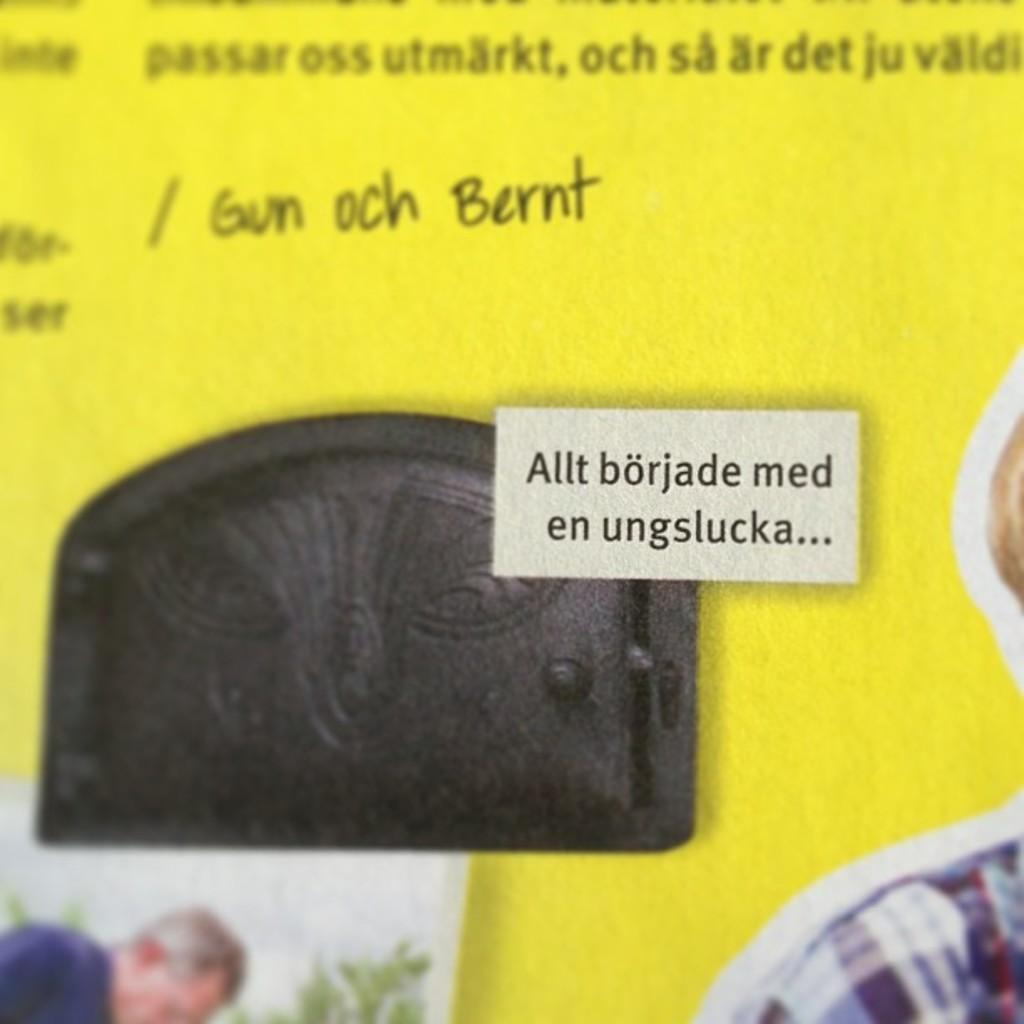What is the main subject of the image? There is a picture in the image. What else can be seen in the image besides the picture? There is text in the image. What color is the background of the image? The background of the image is yellow. How many beads are scattered on the floor in the image? There are no beads present in the image. What type of secretary is shown working in the image? There is no secretary present in the image. 